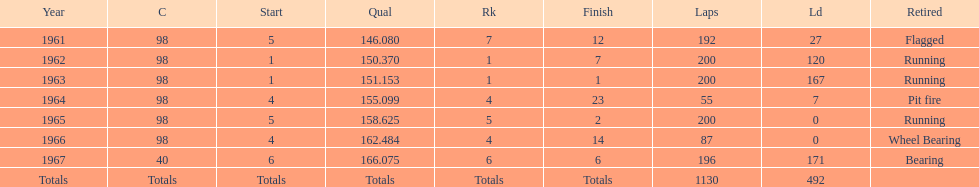In which years did he lead the race the least? 1965, 1966. 